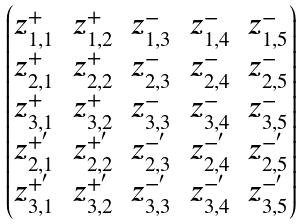<formula> <loc_0><loc_0><loc_500><loc_500>\begin{pmatrix} z _ { 1 , 1 } ^ { + } & z _ { 1 , 2 } ^ { + } & z _ { 1 , 3 } ^ { - } & z _ { 1 , 4 } ^ { - } & z _ { 1 , 5 } ^ { - } \\ z _ { 2 , 1 } ^ { + } & z _ { 2 , 2 } ^ { + } & z _ { 2 , 3 } ^ { - } & z _ { 2 , 4 } ^ { - } & z _ { 2 , 5 } ^ { - } \\ z _ { 3 , 1 } ^ { + } & z _ { 3 , 2 } ^ { + } & z _ { 3 , 3 } ^ { - } & z _ { 3 , 4 } ^ { - } & z _ { 3 , 5 } ^ { - } \\ z _ { 2 , 1 } ^ { + ^ { \prime } } & z _ { 2 , 2 } ^ { + ^ { \prime } } & z _ { 2 , 3 } ^ { - ^ { \prime } } & z _ { 2 , 4 } ^ { - ^ { \prime } } & z _ { 2 , 5 } ^ { - ^ { \prime } } \\ z _ { 3 , 1 } ^ { + ^ { \prime } } & z _ { 3 , 2 } ^ { + ^ { \prime } } & z _ { 3 , 3 } ^ { - ^ { \prime } } & z _ { 3 , 4 } ^ { - ^ { \prime } } & z _ { 3 , 5 } ^ { - ^ { \prime } } \end{pmatrix}</formula> 